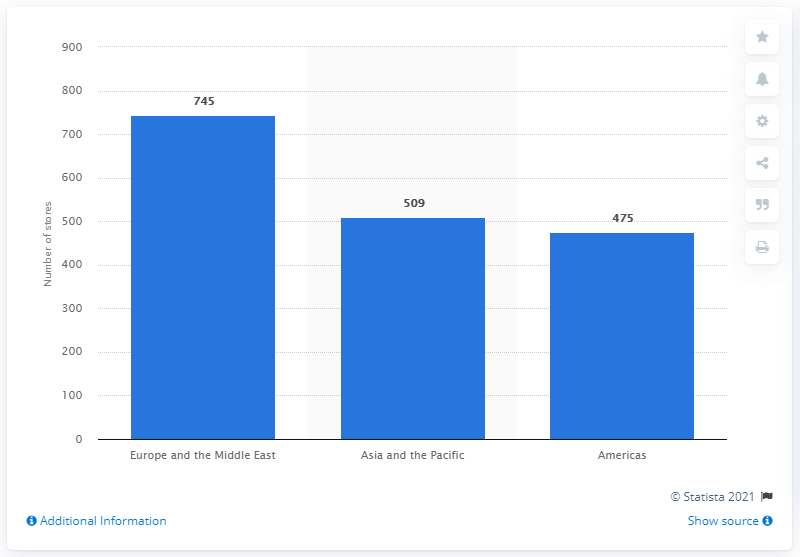Specify some key components in this picture. As of February 1, 2020, Guess operated a total of 745 stores in Europe and the Middle East. 